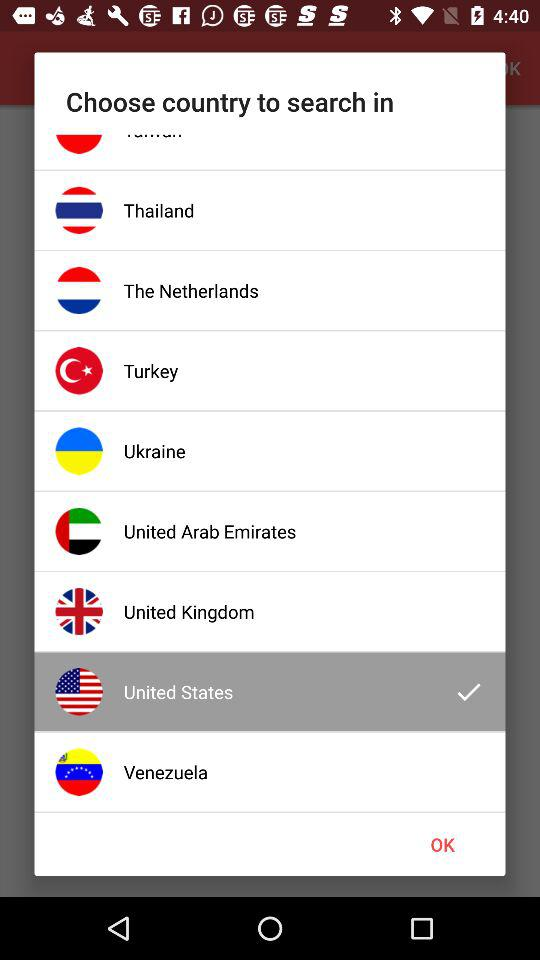What's the chosen country to search in? The chosen country to search in is the United States. 